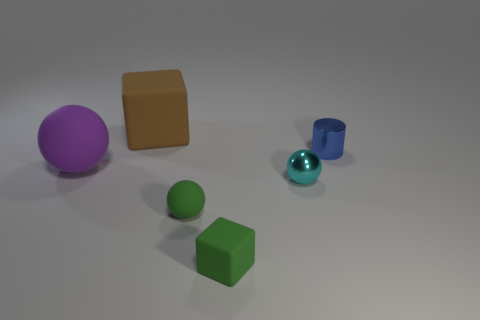The rubber ball in front of the big purple thing is what color?
Provide a short and direct response. Green. What number of other objects are the same color as the shiny cylinder?
Offer a terse response. 0. There is a matte block that is behind the purple thing; is it the same size as the blue object?
Provide a succinct answer. No. What number of cyan shiny objects are on the right side of the green rubber ball?
Provide a short and direct response. 1. Are there any green rubber balls of the same size as the cylinder?
Your answer should be compact. Yes. Is the small rubber ball the same color as the small cube?
Keep it short and to the point. Yes. The rubber cube to the left of the matte block in front of the cyan shiny ball is what color?
Your answer should be very brief. Brown. How many objects are both right of the brown matte thing and behind the purple object?
Make the answer very short. 1. How many other brown objects are the same shape as the large brown matte thing?
Give a very brief answer. 0. Are the purple thing and the large brown block made of the same material?
Make the answer very short. Yes. 